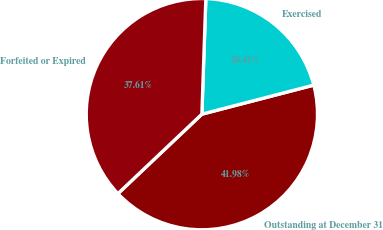Convert chart. <chart><loc_0><loc_0><loc_500><loc_500><pie_chart><fcel>Outstanding at December 31<fcel>Exercised<fcel>Forfeited or Expired<nl><fcel>41.98%<fcel>20.41%<fcel>37.61%<nl></chart> 